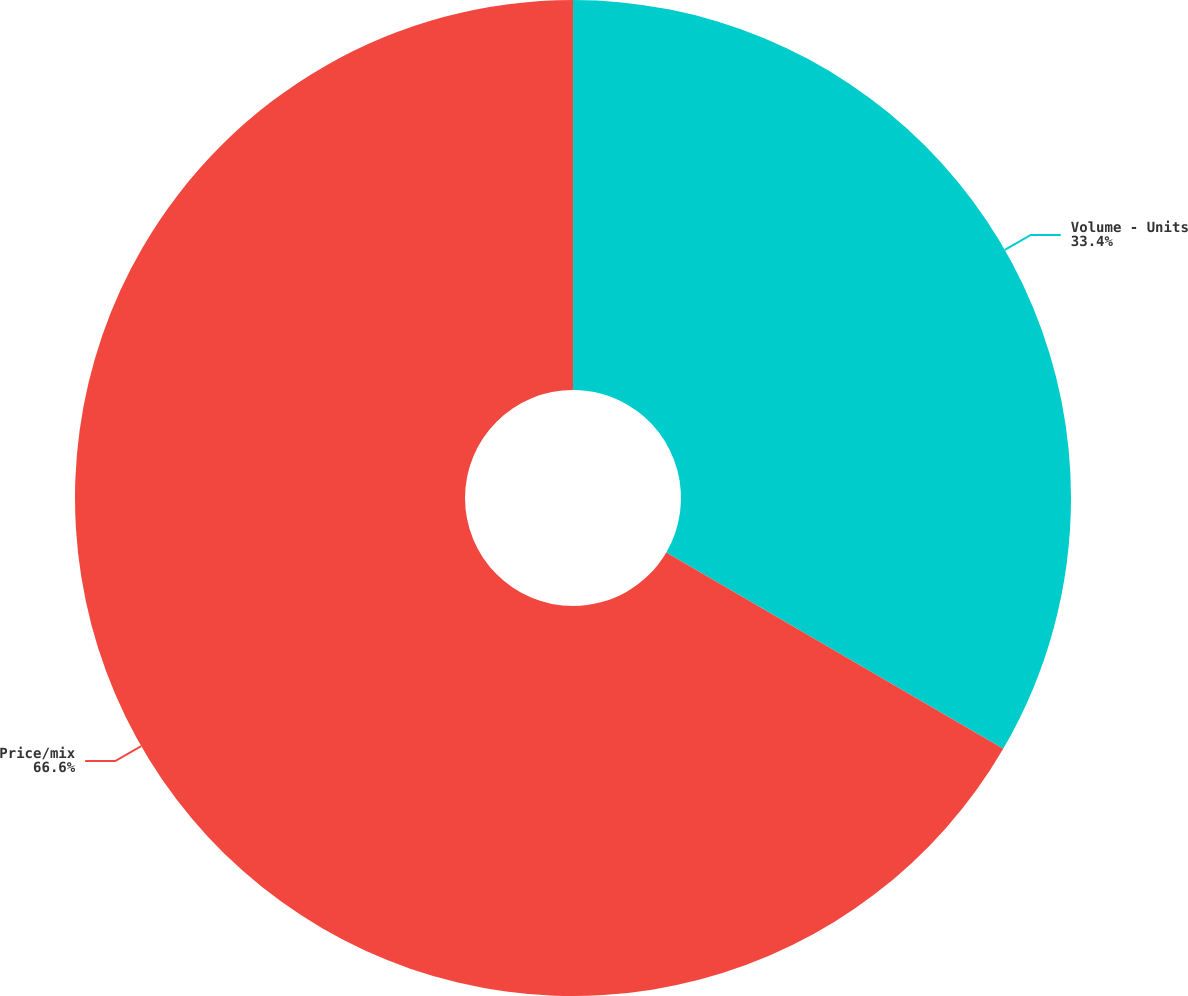Convert chart to OTSL. <chart><loc_0><loc_0><loc_500><loc_500><pie_chart><fcel>Volume - Units<fcel>Price/mix<nl><fcel>33.4%<fcel>66.6%<nl></chart> 